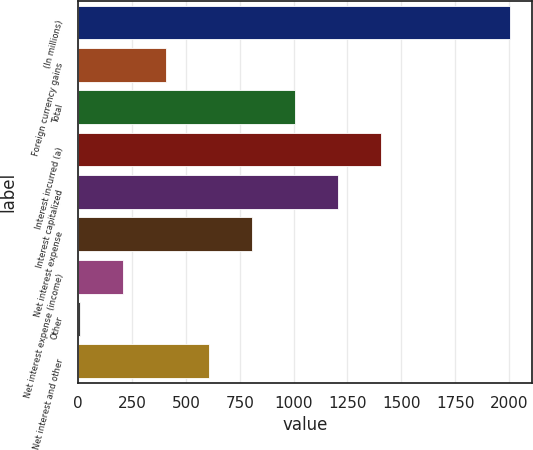<chart> <loc_0><loc_0><loc_500><loc_500><bar_chart><fcel>(In millions)<fcel>Foreign currency gains<fcel>Total<fcel>Interest incurred (a)<fcel>Interest capitalized<fcel>Net interest expense<fcel>Net interest expense (income)<fcel>Other<fcel>Net interest and other<nl><fcel>2006<fcel>409.2<fcel>1008<fcel>1407.2<fcel>1207.6<fcel>808.4<fcel>209.6<fcel>10<fcel>608.8<nl></chart> 